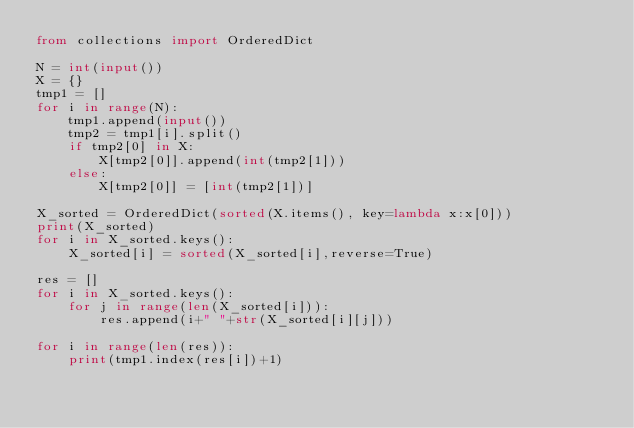Convert code to text. <code><loc_0><loc_0><loc_500><loc_500><_Python_>from collections import OrderedDict

N = int(input())
X = {}
tmp1 = []
for i in range(N):
    tmp1.append(input())
    tmp2 = tmp1[i].split()
    if tmp2[0] in X:
        X[tmp2[0]].append(int(tmp2[1]))
    else:
        X[tmp2[0]] = [int(tmp2[1])]

X_sorted = OrderedDict(sorted(X.items(), key=lambda x:x[0]))
print(X_sorted)
for i in X_sorted.keys():
    X_sorted[i] = sorted(X_sorted[i],reverse=True)

res = []
for i in X_sorted.keys():
    for j in range(len(X_sorted[i])):
        res.append(i+" "+str(X_sorted[i][j]))

for i in range(len(res)):
    print(tmp1.index(res[i])+1)</code> 